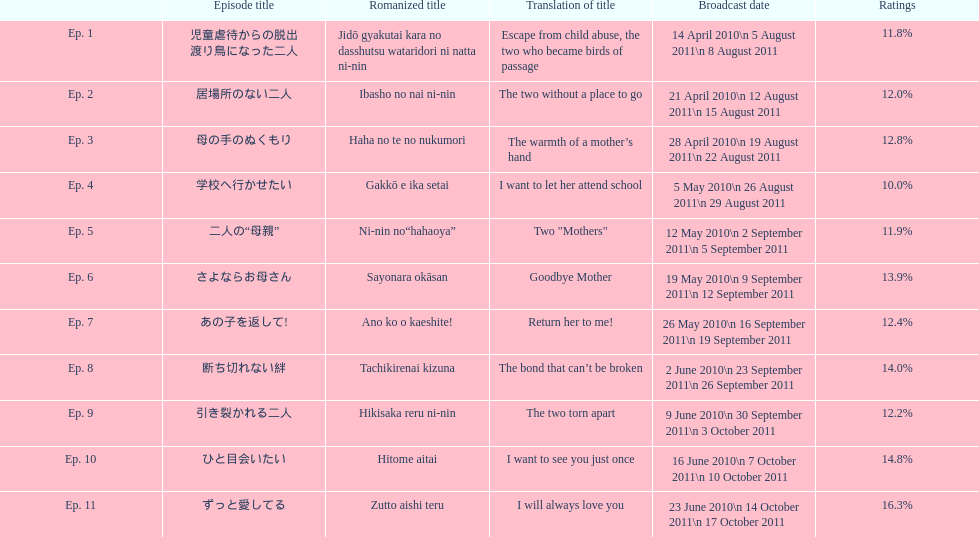How many continuous episodes received a rating of more than 11%? 7. 